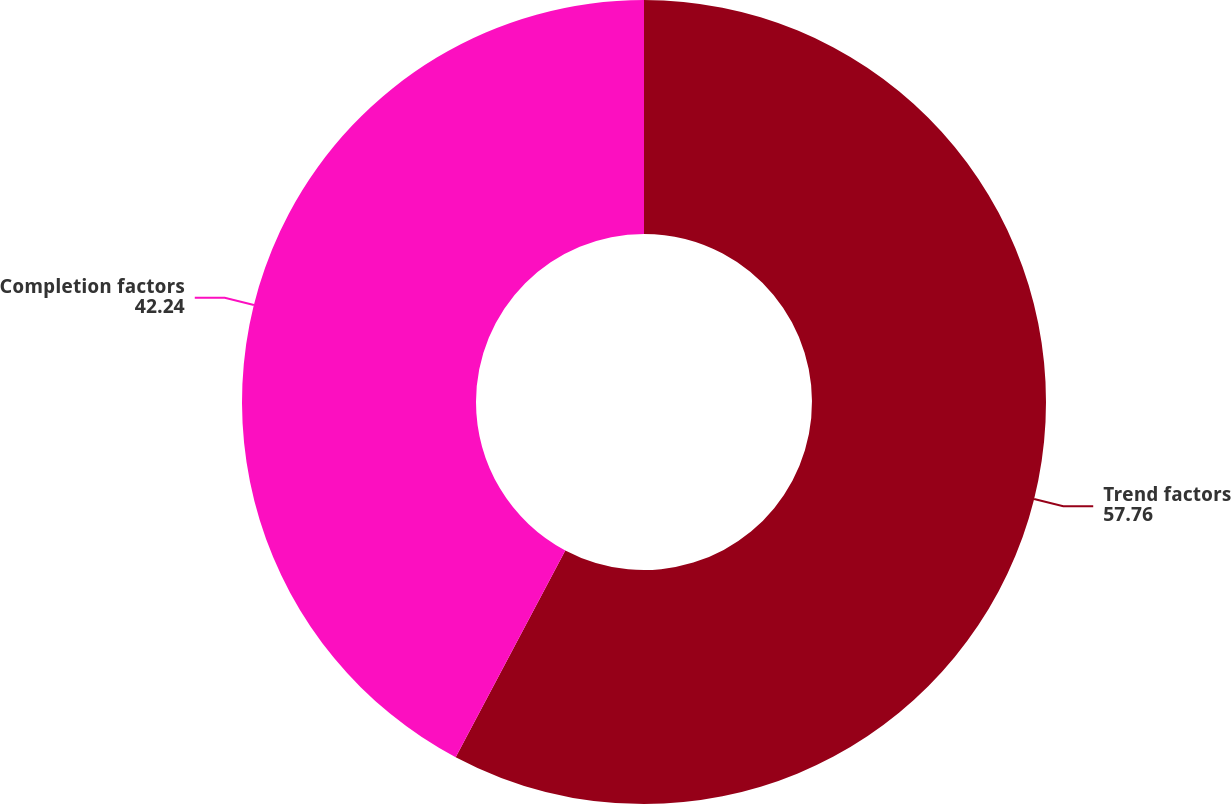<chart> <loc_0><loc_0><loc_500><loc_500><pie_chart><fcel>Trend factors<fcel>Completion factors<nl><fcel>57.76%<fcel>42.24%<nl></chart> 